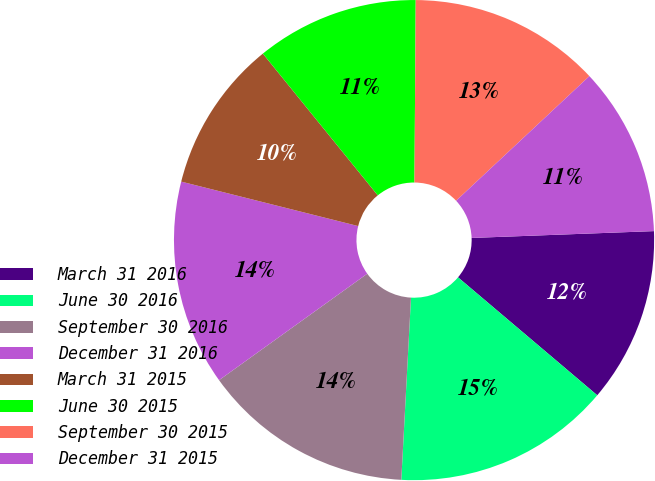<chart> <loc_0><loc_0><loc_500><loc_500><pie_chart><fcel>March 31 2016<fcel>June 30 2016<fcel>September 30 2016<fcel>December 31 2016<fcel>March 31 2015<fcel>June 30 2015<fcel>September 30 2015<fcel>December 31 2015<nl><fcel>11.78%<fcel>14.66%<fcel>14.24%<fcel>13.83%<fcel>10.24%<fcel>10.95%<fcel>12.92%<fcel>11.37%<nl></chart> 